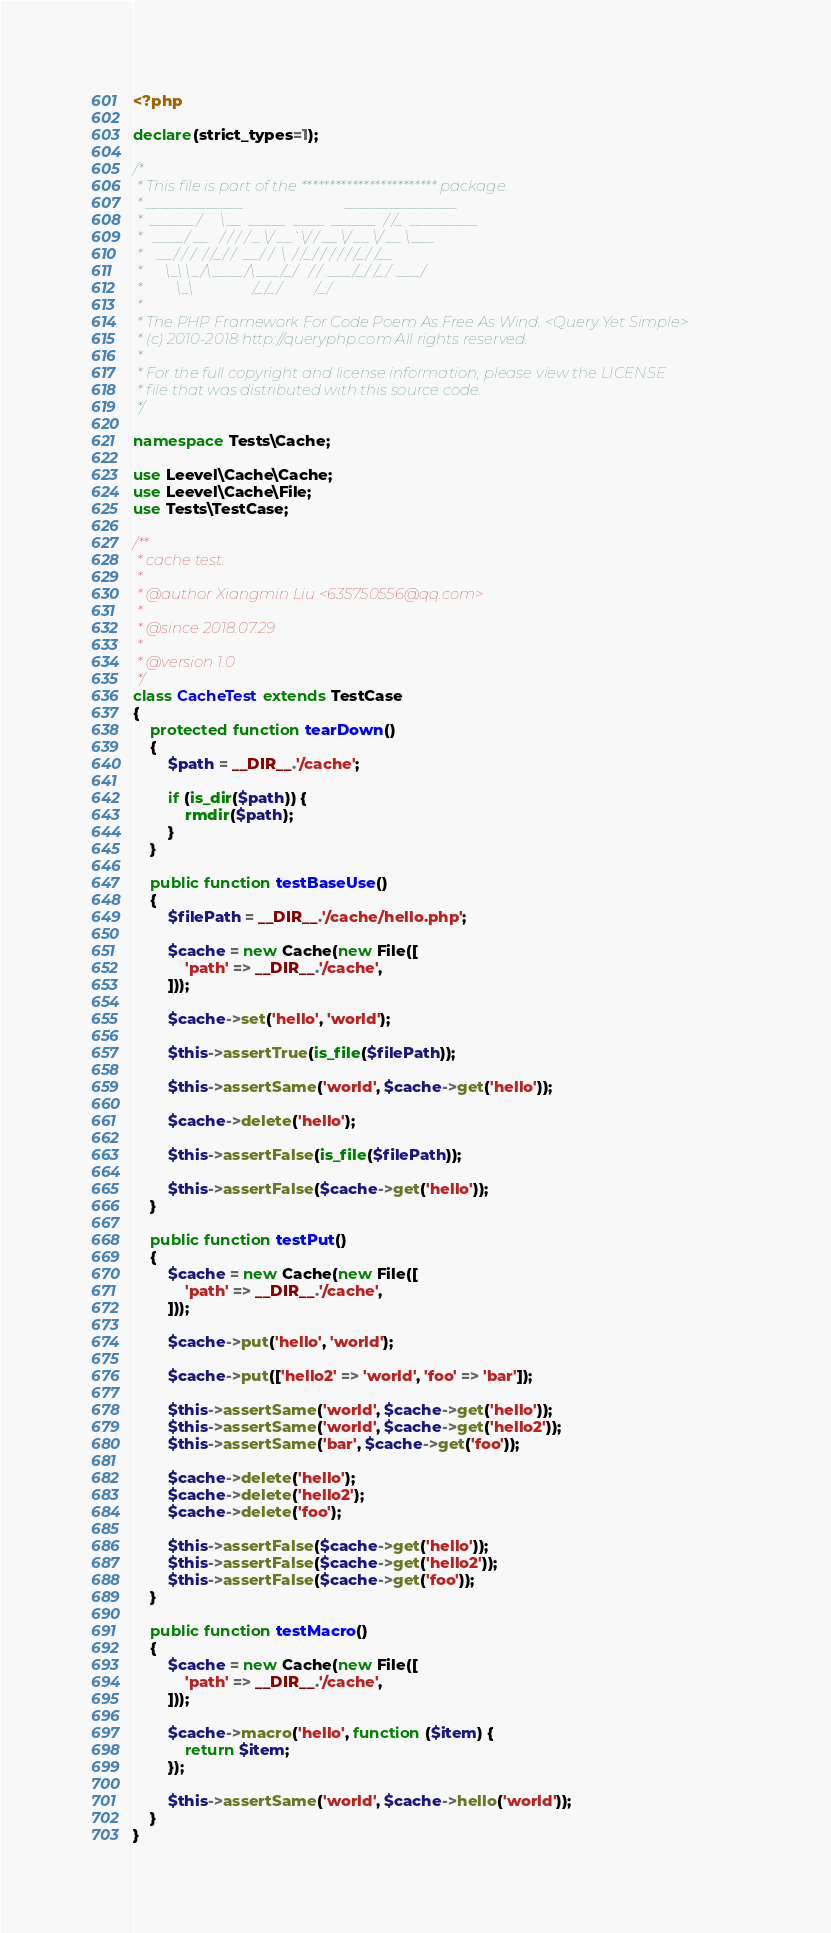Convert code to text. <code><loc_0><loc_0><loc_500><loc_500><_PHP_><?php

declare(strict_types=1);

/*
 * This file is part of the ************************ package.
 * _____________                           _______________
 *  ______/     \__  _____  ____  ______  / /_  _________
 *   ____/ __   / / / / _ \/ __`\/ / __ \/ __ \/ __ \___
 *    __/ / /  / /_/ /  __/ /  \  / /_/ / / / / /_/ /__
 *      \_\ \_/\____/\___/_/   / / .___/_/ /_/ .___/
 *         \_\                /_/_/         /_/
 *
 * The PHP Framework For Code Poem As Free As Wind. <Query Yet Simple>
 * (c) 2010-2018 http://queryphp.com All rights reserved.
 *
 * For the full copyright and license information, please view the LICENSE
 * file that was distributed with this source code.
 */

namespace Tests\Cache;

use Leevel\Cache\Cache;
use Leevel\Cache\File;
use Tests\TestCase;

/**
 * cache test.
 *
 * @author Xiangmin Liu <635750556@qq.com>
 *
 * @since 2018.07.29
 *
 * @version 1.0
 */
class CacheTest extends TestCase
{
    protected function tearDown()
    {
        $path = __DIR__.'/cache';

        if (is_dir($path)) {
            rmdir($path);
        }
    }

    public function testBaseUse()
    {
        $filePath = __DIR__.'/cache/hello.php';

        $cache = new Cache(new File([
            'path' => __DIR__.'/cache',
        ]));

        $cache->set('hello', 'world');

        $this->assertTrue(is_file($filePath));

        $this->assertSame('world', $cache->get('hello'));

        $cache->delete('hello');

        $this->assertFalse(is_file($filePath));

        $this->assertFalse($cache->get('hello'));
    }

    public function testPut()
    {
        $cache = new Cache(new File([
            'path' => __DIR__.'/cache',
        ]));

        $cache->put('hello', 'world');

        $cache->put(['hello2' => 'world', 'foo' => 'bar']);

        $this->assertSame('world', $cache->get('hello'));
        $this->assertSame('world', $cache->get('hello2'));
        $this->assertSame('bar', $cache->get('foo'));

        $cache->delete('hello');
        $cache->delete('hello2');
        $cache->delete('foo');

        $this->assertFalse($cache->get('hello'));
        $this->assertFalse($cache->get('hello2'));
        $this->assertFalse($cache->get('foo'));
    }

    public function testMacro()
    {
        $cache = new Cache(new File([
            'path' => __DIR__.'/cache',
        ]));

        $cache->macro('hello', function ($item) {
            return $item;
        });

        $this->assertSame('world', $cache->hello('world'));
    }
}
</code> 